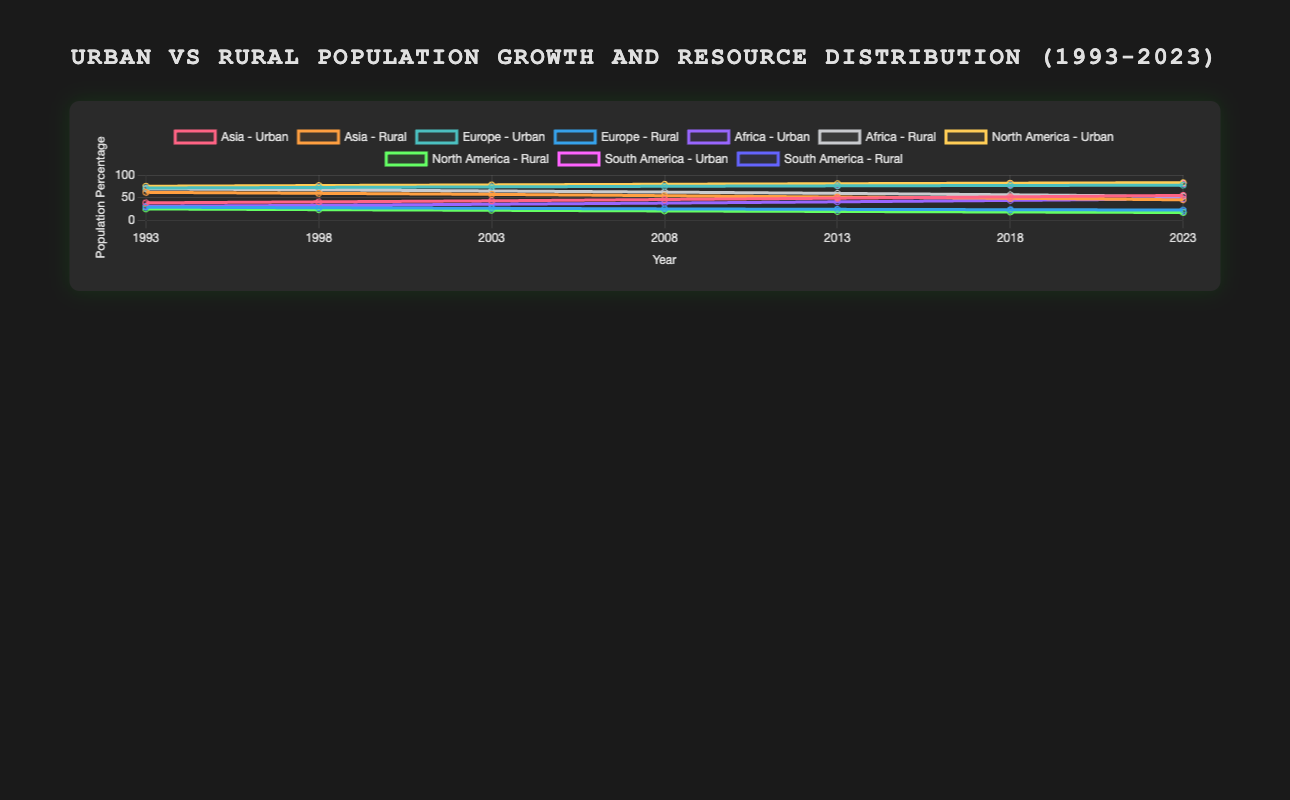What has been the trend of urban population growth in Asia over the last three decades? By looking at the figure, we can observe that the urban population in Asia has consistently increased from 38.4% in 1993 to 54.9% in 2023. This indicates a clear upward trend over the last three decades.
Answer: Increasing How does the rural population in Europe in 1993 compare to that in 2023? The rural population in Europe has decreased from 28.8% in 1993 to 22.5% in 2023. This shows a decline over the last three decades.
Answer: Decreased Which region shows the most significant decrease in its rural population from 1993 to 2023? By comparing the rural population changes in each region, Africa shows the most significant decrease from 69.3% in 1993 to 52.8% in 2023, a 16.5 percentage point drop.
Answer: Africa Compare the healthcare resource distribution trends between North America and South America from 1993 to 2023. From the figure, both North America and South America show an increasing trend in healthcare resource distribution. North America's healthcare resources grew from 580 to 709 units, while South America's grew from 340 to 418 units. However, the increase in North America is higher both numerically and proportionally.
Answer: Both increased, North America more What year marked the first time urban population surpassed rural population in Asia? By examining the intersecting points of the urban and rural population lines for Asia, we see that 2018 is the year when urban population (51.61%) surpassed rural population (48.39%).
Answer: 2018 Which region had the highest percentage of urban population in 2023, and what was that percentage? In 2023, North America had the highest percentage of urban population at 83.0%, as seen by comparing the highest points of the urban population lines across all regions in the figure.
Answer: North America, 83.0% How has the infrastructure resource distribution in Africa changed over the last three decades? The infrastructure resource distribution in Africa has increased significantly from 320 units in 1993 to 746 units in 2023, showing a clear improving trend.
Answer: Increased In which year did Europe surpass a 75% urban population, and how did its rural population correlate at that time? Europe surpassed a 75% urban population in 2008 (75.0%). At the same time, its rural population had decreased to 25.0%, maintaining a reciprocal correlation.
Answer: 2008, 25.0% Compare the education resource distribution growth from 1993 to 2023 between Asia and Africa. From the figure, Asia's education resources have increased from 552 to 838 units, while Africa's education resources have increased from 180 to 291 units. Although both regions have seen growth, Asia's increase is more substantial both numerically and proportionally.
Answer: Asia increased more What are the trends in the urban and rural population in South America, and what does this imply about its urbanization? In South America, the urban population has grown from 71.4% to 81.0%, while the rural population has decreased from 28.6% to 19.0%, indicating a clear trend towards urbanization.
Answer: Increasing urban, decreasing rural, implies urbanization 